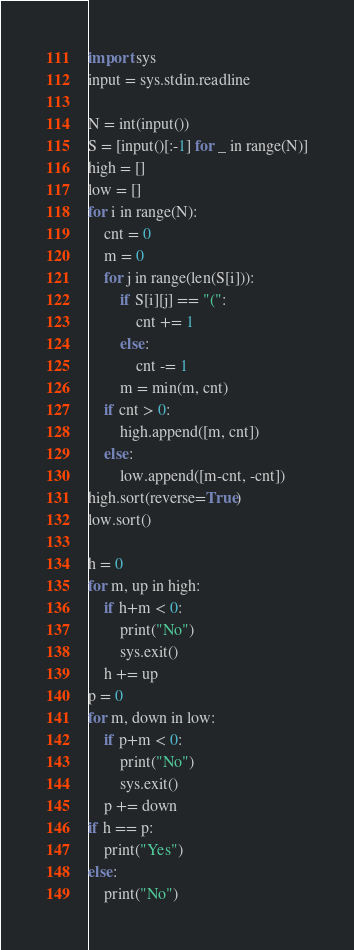<code> <loc_0><loc_0><loc_500><loc_500><_Python_>import sys
input = sys.stdin.readline

N = int(input())
S = [input()[:-1] for _ in range(N)]
high = []
low = []
for i in range(N):
    cnt = 0
    m = 0
    for j in range(len(S[i])):
        if S[i][j] == "(":
            cnt += 1
        else:
            cnt -= 1
        m = min(m, cnt)
    if cnt > 0:
        high.append([m, cnt])
    else:
        low.append([m-cnt, -cnt])
high.sort(reverse=True)
low.sort()

h = 0
for m, up in high:
    if h+m < 0:
        print("No")
        sys.exit()
    h += up
p = 0
for m, down in low:
    if p+m < 0:
        print("No")
        sys.exit()
    p += down
if h == p:
    print("Yes")
else:
    print("No")


</code> 